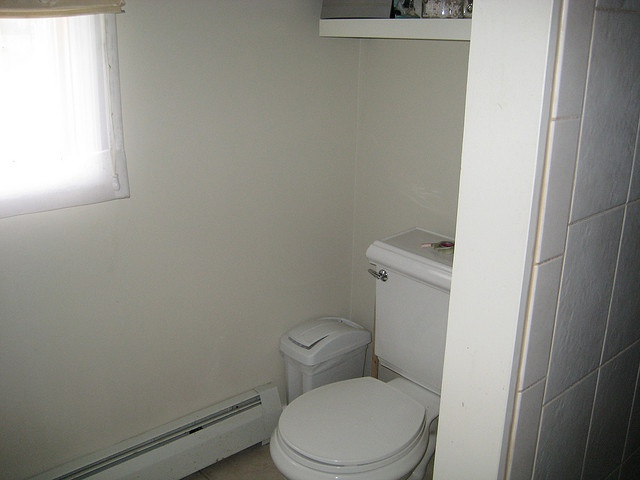Describe the objects in this image and their specific colors. I can see a toilet in gray and darkgray tones in this image. 